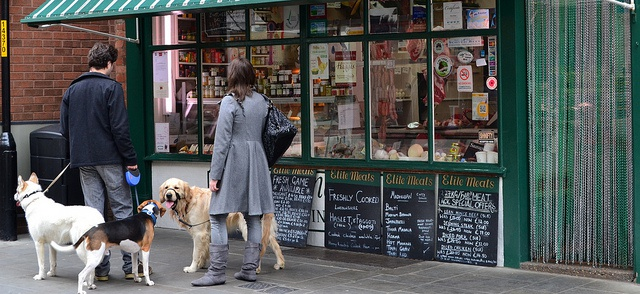Describe the objects in this image and their specific colors. I can see people in black, gray, and darkgray tones, people in black and gray tones, dog in black, white, darkgray, and gray tones, dog in black, white, darkgray, lightgray, and gray tones, and dog in black, darkgray, tan, and gray tones in this image. 